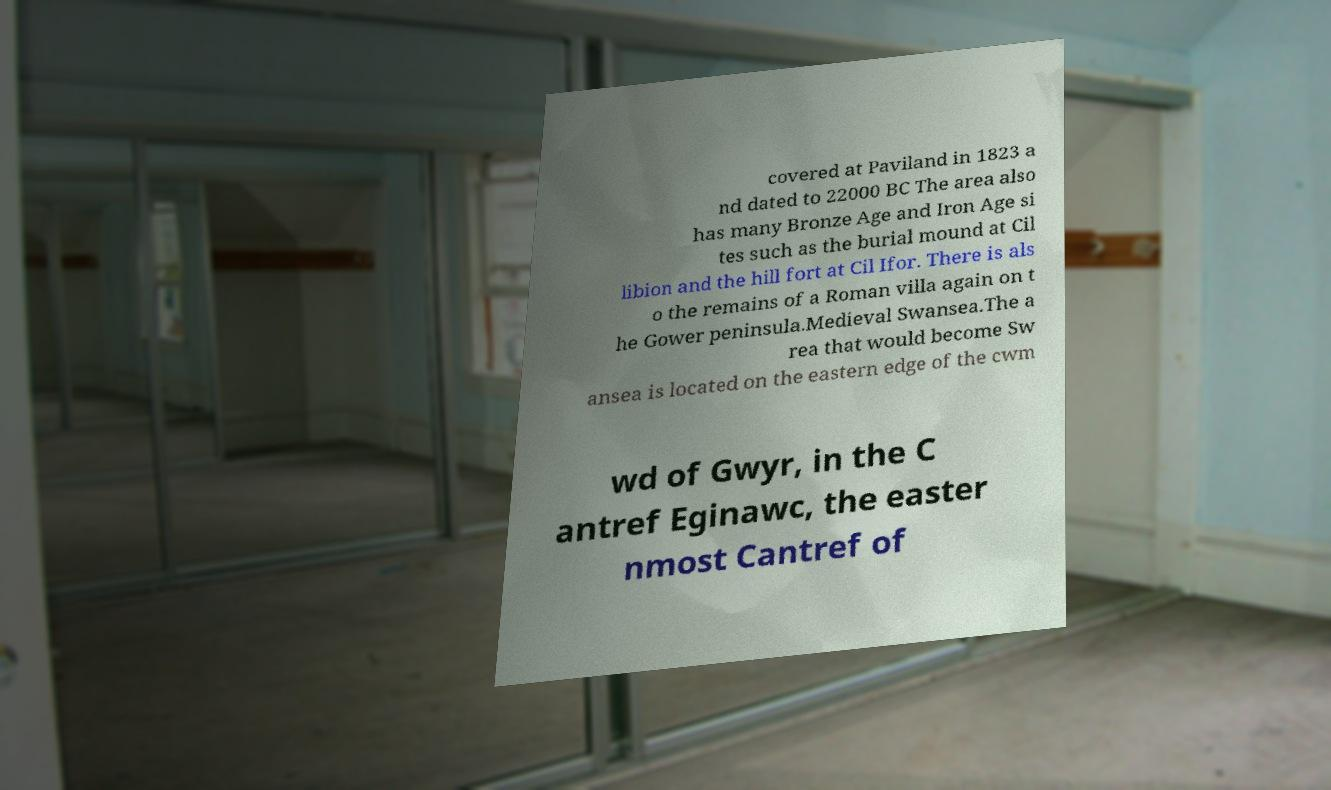Can you read and provide the text displayed in the image?This photo seems to have some interesting text. Can you extract and type it out for me? covered at Paviland in 1823 a nd dated to 22000 BC The area also has many Bronze Age and Iron Age si tes such as the burial mound at Cil libion and the hill fort at Cil Ifor. There is als o the remains of a Roman villa again on t he Gower peninsula.Medieval Swansea.The a rea that would become Sw ansea is located on the eastern edge of the cwm wd of Gwyr, in the C antref Eginawc, the easter nmost Cantref of 